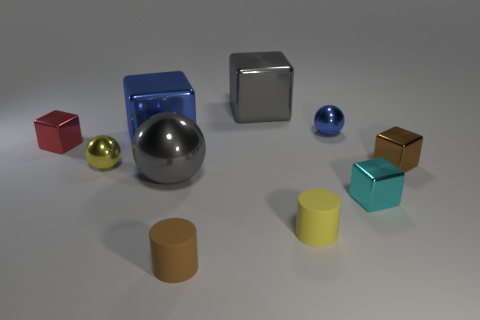Subtract all tiny spheres. How many spheres are left? 1 Subtract all blue cubes. How many cubes are left? 4 Subtract 1 balls. How many balls are left? 2 Subtract all yellow blocks. Subtract all red balls. How many blocks are left? 5 Add 3 large metal things. How many large metal things exist? 6 Subtract 0 gray cylinders. How many objects are left? 10 Subtract all balls. How many objects are left? 7 Subtract all tiny metal blocks. Subtract all tiny yellow rubber objects. How many objects are left? 6 Add 8 small cylinders. How many small cylinders are left? 10 